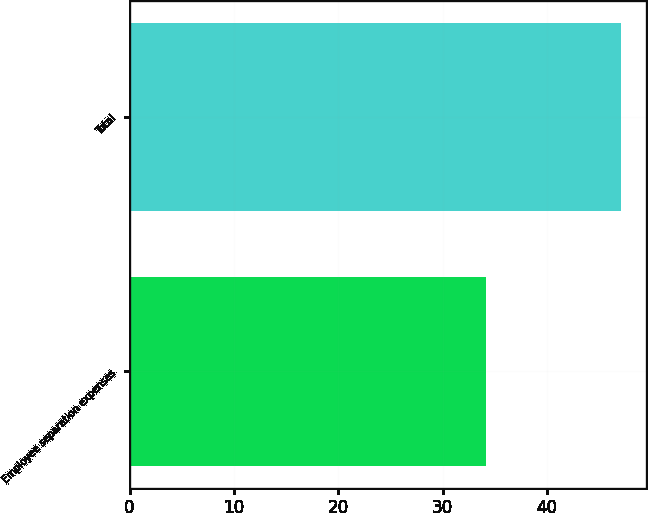Convert chart to OTSL. <chart><loc_0><loc_0><loc_500><loc_500><bar_chart><fcel>Employee separation expenses<fcel>Total<nl><fcel>34.2<fcel>47.1<nl></chart> 